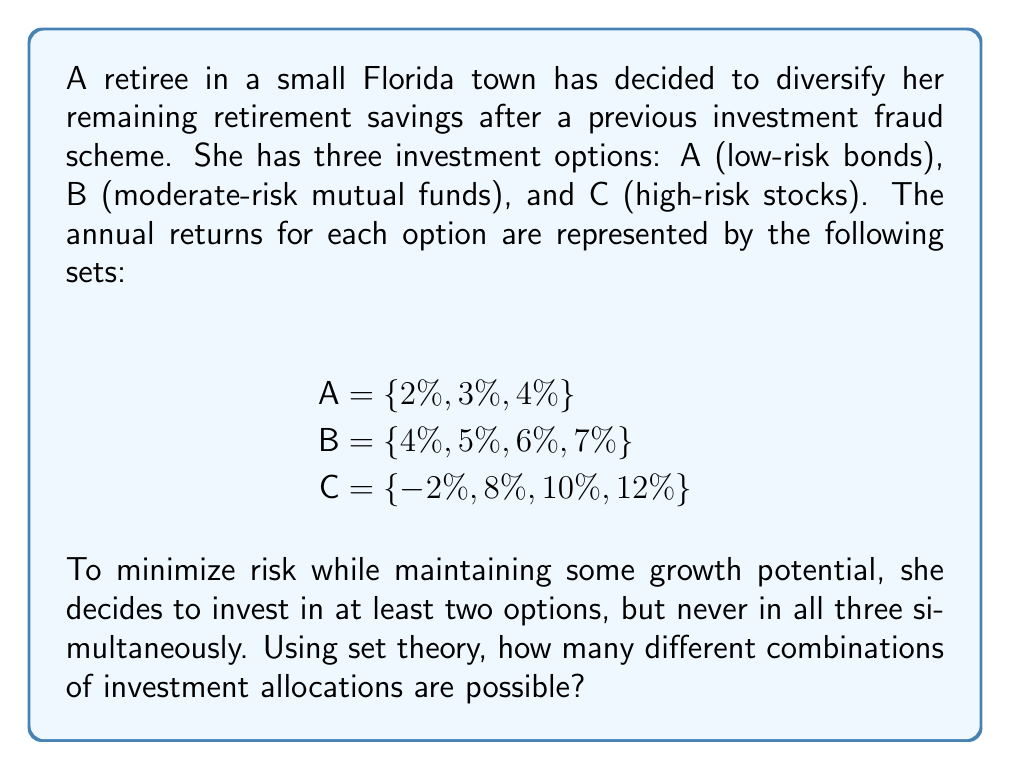Can you answer this question? To solve this problem, we'll use set theory concepts, specifically the power set and set operations.

1. First, let's consider the universal set $U = \{A, B, C\}$, which represents all investment options.

2. We need to find all subsets of $U$ that contain at least two elements, but not all three. This can be calculated by subtracting the number of single-element subsets and the set with all elements from the total number of subsets (power set).

3. The number of elements in the power set of a set with $n$ elements is $2^n$. Here, $n = 3$, so the total number of subsets is $2^3 = 8$.

4. The subsets we want to exclude are:
   - Single-element subsets: $\{A\}, \{B\}, \{C\}$ (3 in total)
   - The set with all elements: $\{A, B, C\}$ (1 in total)

5. Therefore, the number of valid investment combinations is:
   $$(2^3) - 3 - 1 = 8 - 3 - 1 = 4$$

6. These four combinations are:
   $\{A, B\}, \{A, C\}, \{B, C\}, \{A, B, C\}$

Thus, there are 4 different combinations of investment allocations possible that meet the retiree's criteria.
Answer: 4 combinations 